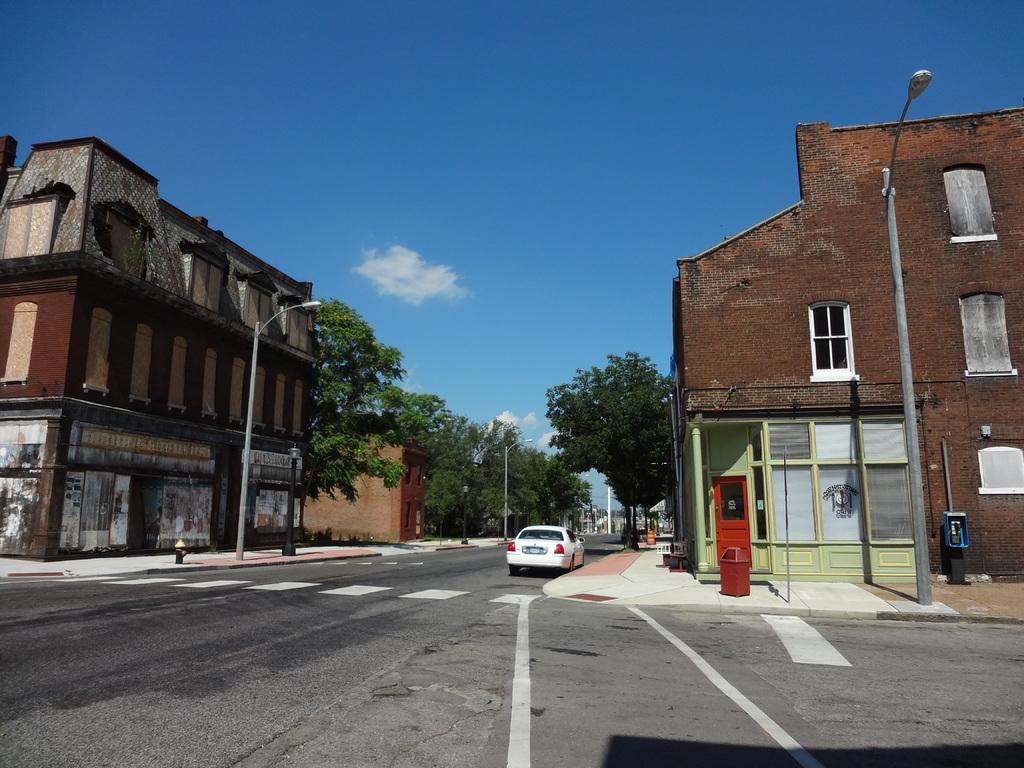Could you give a brief overview of what you see in this image? There is a car on the road. Here we can see poles, trees, buildings, boards, lights, windows, and a bin. In the background there is sky with clouds. 